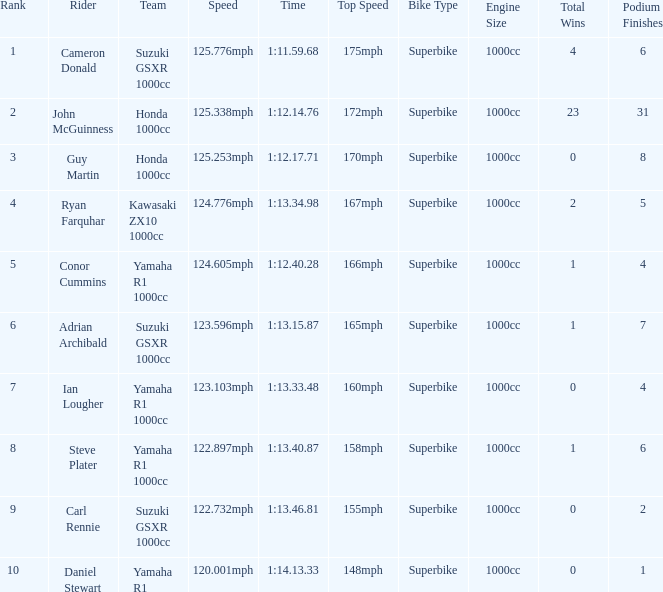What time did team kawasaki zx10 1000cc have? 1:13.34.98. 